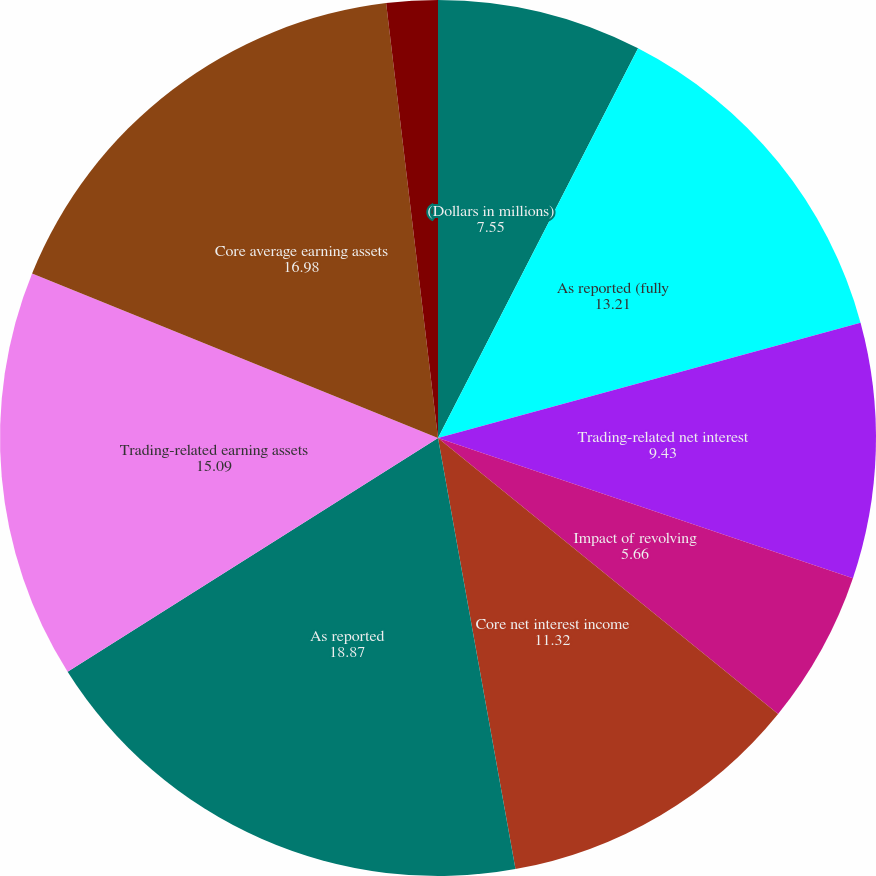<chart> <loc_0><loc_0><loc_500><loc_500><pie_chart><fcel>(Dollars in millions)<fcel>As reported (fully<fcel>Trading-related net interest<fcel>Impact of revolving<fcel>Core net interest income<fcel>As reported<fcel>Trading-related earning assets<fcel>Core average earning assets<fcel>(fully taxable-equivalent<fcel>Impact of trading-related<nl><fcel>7.55%<fcel>13.21%<fcel>9.43%<fcel>5.66%<fcel>11.32%<fcel>18.87%<fcel>15.09%<fcel>16.98%<fcel>1.89%<fcel>0.0%<nl></chart> 